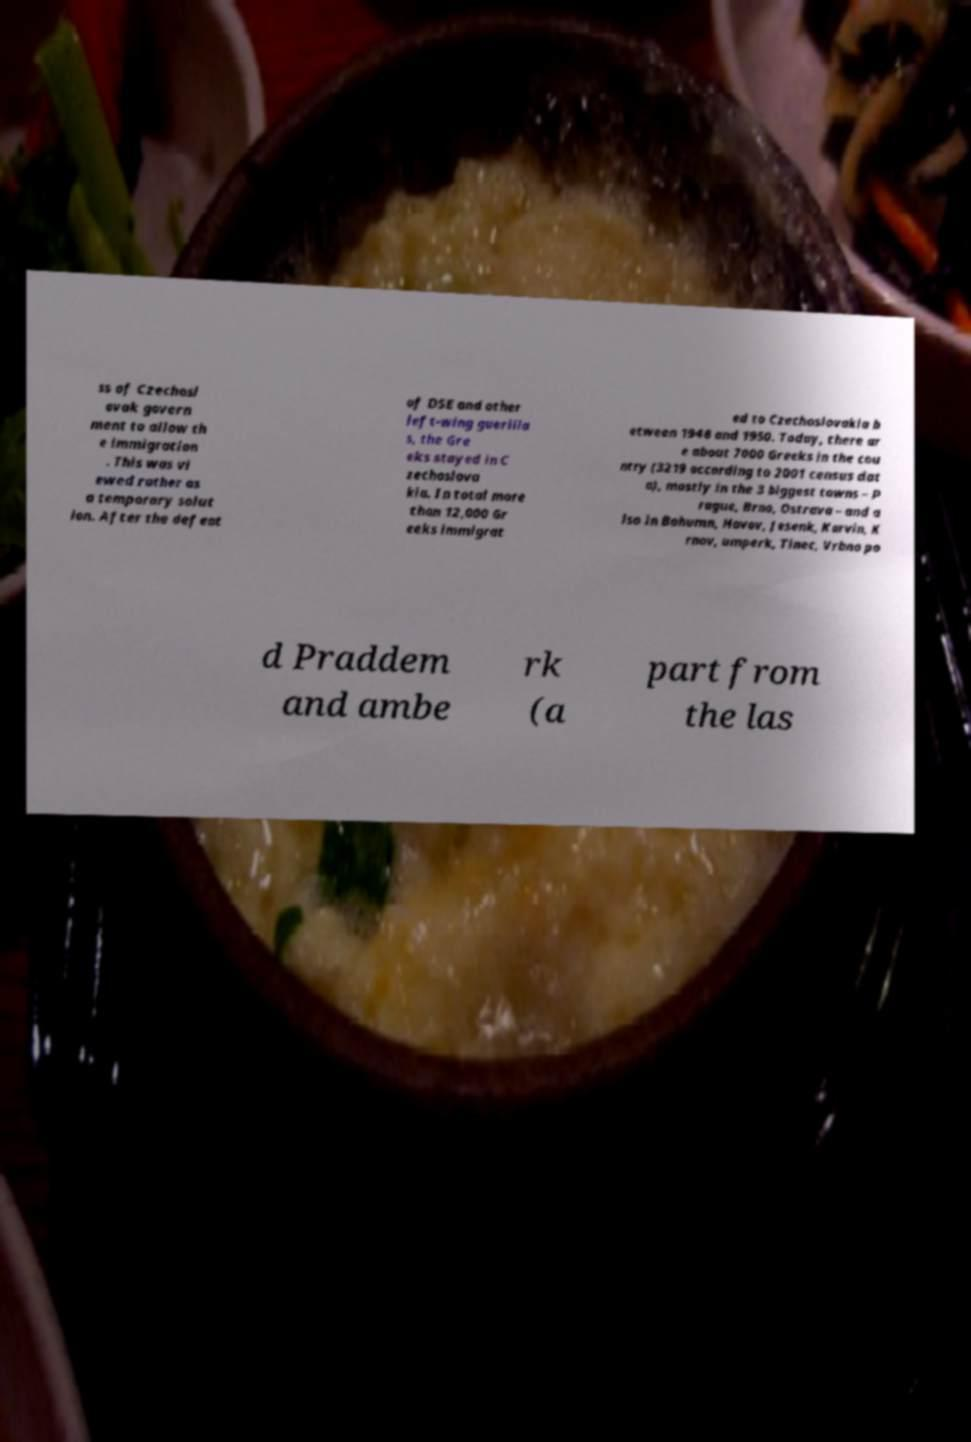I need the written content from this picture converted into text. Can you do that? ss of Czechosl ovak govern ment to allow th e immigration . This was vi ewed rather as a temporary solut ion. After the defeat of DSE and other left-wing guerilla s, the Gre eks stayed in C zechoslova kia. In total more than 12,000 Gr eeks immigrat ed to Czechoslovakia b etween 1948 and 1950. Today, there ar e about 7000 Greeks in the cou ntry (3219 according to 2001 census dat a), mostly in the 3 biggest towns – P rague, Brno, Ostrava – and a lso in Bohumn, Havov, Jesenk, Karvin, K rnov, umperk, Tinec, Vrbno po d Praddem and ambe rk (a part from the las 